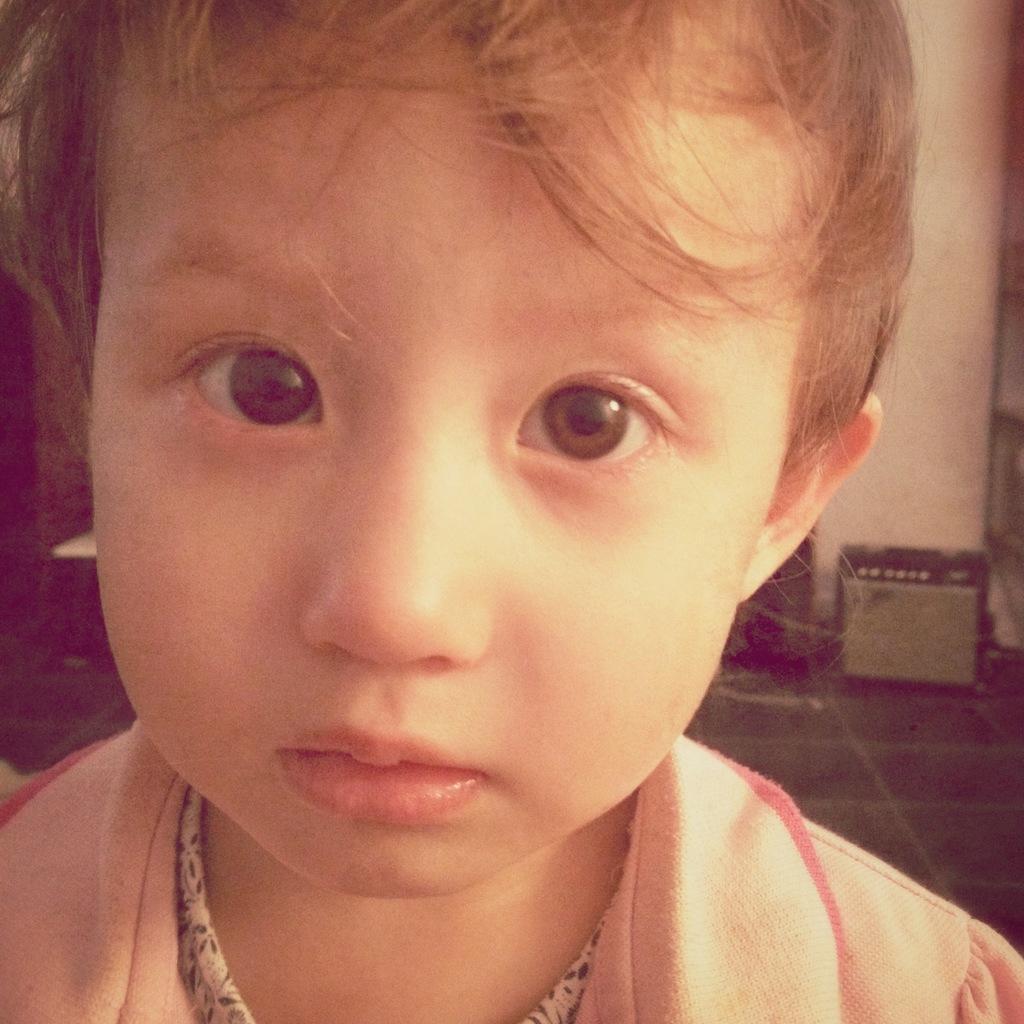Could you give a brief overview of what you see in this image? Here we can see a kid. In the background we can see an object and a racks stand on the floor and this is a wall. 